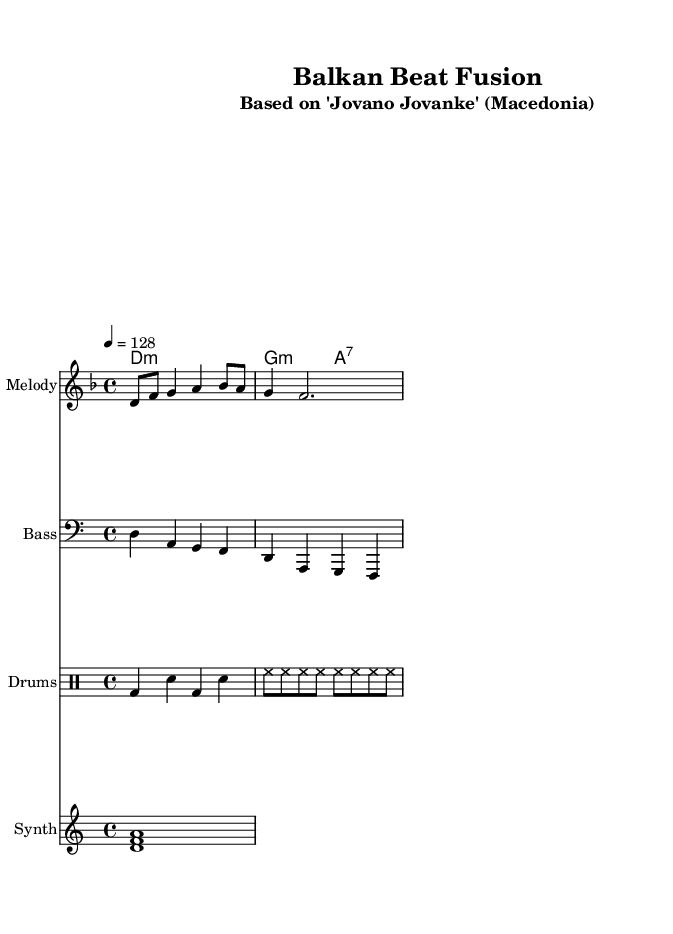What is the key signature of this music? The key signature is D minor, which is indicated by one flat. In the sheet music, there is a note indicating the key signature D minor at the beginning of the staves.
Answer: D minor What is the time signature of this music? The time signature displayed in the sheet music is 4/4, which means there are four beats in a measure and a quarter note receives one beat. This can be identified through the notation at the start of the piece.
Answer: 4/4 What is the tempo marking of this piece? The tempo marking indicates that the piece should be played at a speed of 128 beats per minute. This is noted at the beginning of the score and denotes the pace of the dance rhythm.
Answer: 128 How many measures are in the melody line? By counting the segments of the melody, we can see there are 2 complete measures indicated by the notes present in the staff. Each measure is separated by a vertical line.
Answer: 2 What instruments are present in this arrangement? The sheet music includes a melody, bass, drums, and synth parts, which are each labeled at the start of each staff. This showcases a typical arrangement for high-energy dance music.
Answer: Melody, Bass, Drums, Synth What type of music is this arrangement based on? The arrangement is based on the traditional Macedonian folk song "Jovano Jovanke," which the title notes. This is relevant to the genre of dance music, particularly in this context of high-energy remixes.
Answer: Jovano Jovanke 